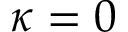<formula> <loc_0><loc_0><loc_500><loc_500>\kappa = 0</formula> 